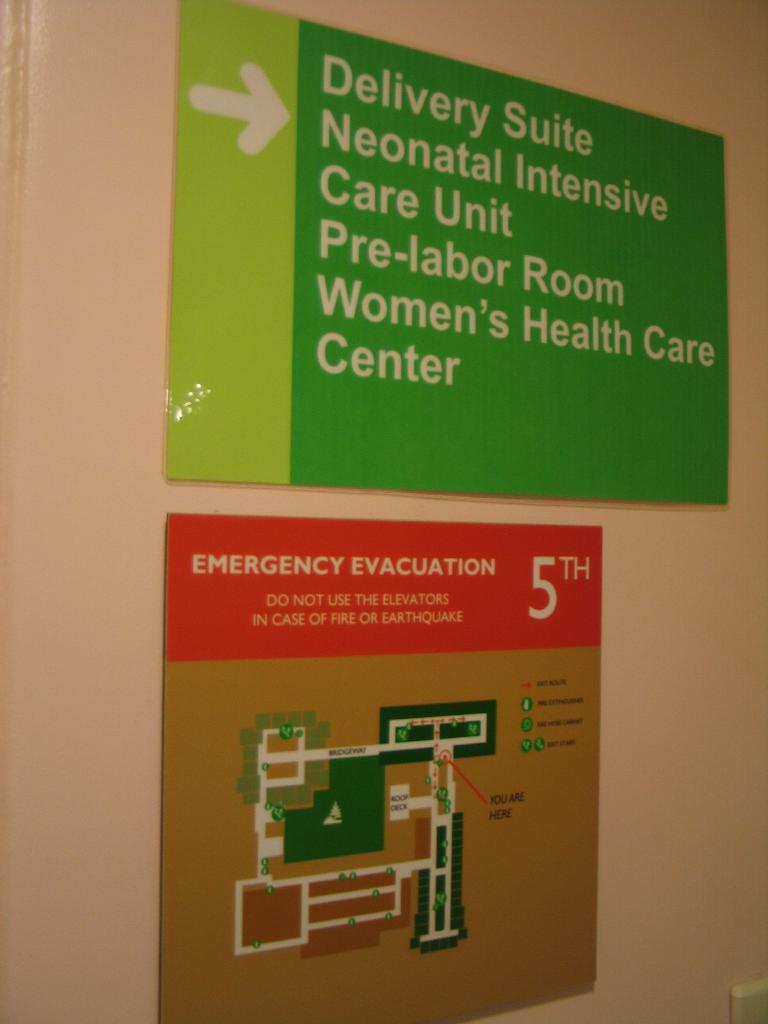Describe this image in one or two sentences. In this image we can see a wall with boards and an object. 